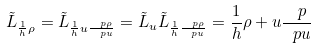<formula> <loc_0><loc_0><loc_500><loc_500>\tilde { L } _ { \frac { 1 } { h } \rho } = \tilde { L } _ { \frac { 1 } { h } u \frac { \ p \rho } { \ p u } } = \tilde { L } _ { u } \tilde { L } _ { \frac { 1 } { h } \frac { \ p \rho } { \ p u } } = \frac { 1 } { h } \rho + u \frac { \ p } { \ p u }</formula> 